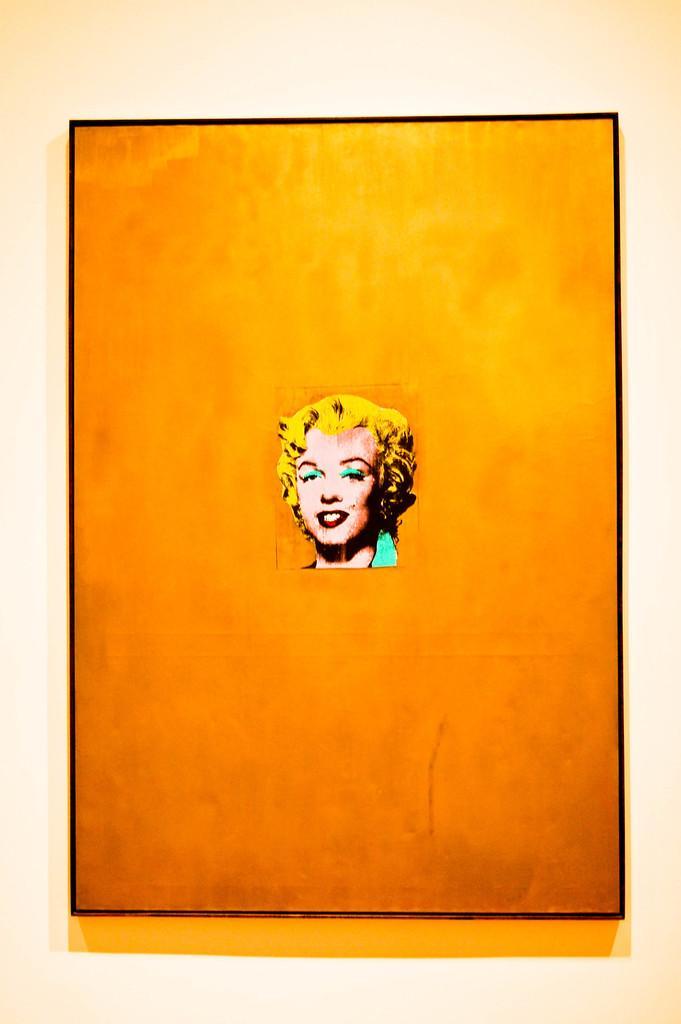Please provide a concise description of this image. In this picture we can see a photo frame, there is a picture of a person's face in the frame, we can see a plane background. 